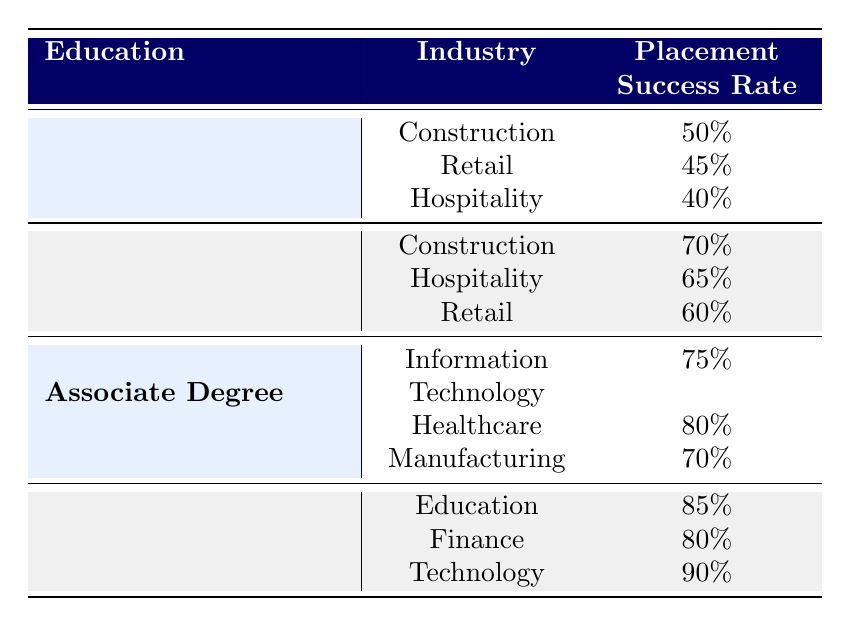What is the placement success rate for individuals with a High School Diploma in Hospitality? According to the table, the placement success rate for individuals with a High School Diploma in Hospitality is listed directly next to that category, which shows a rate of 65%.
Answer: 65% Which industry has the highest placement success rate for individuals with a Bachelor's Degree? Referring to the table, the placement success rates for individuals with a Bachelor's Degree across different industries are 85%, 80%, and 90%. The highest among these is 90% in Technology.
Answer: 90% Is the placement success rate for individuals with No Formal Education in Retail higher than that in Hospitality? In the table, the success rate for individuals with No Formal Education in Retail is 45%, while the rate in Hospitality is 40%. Since 45% is greater than 40%, the statement is true.
Answer: Yes What is the total placement success rate for Associate Degree holders across all industries listed? To find the total placement success rate for Associate Degree holders, add their rates together: 75% + 80% + 70% = 225%. To find the average, divide by the number of industries (3), resulting in an average rate of 75%.
Answer: 75% Does the industry Construction have a higher placement success rate for High School Diploma holders compared to No Formal Education? In the table, the placement success rate for Construction with a High School Diploma is 70%, while for No Formal Education it is 50%. Since 70% is greater than 50%, the statement is true.
Answer: Yes What is the difference in placement success rates between individuals with a Bachelor's Degree in Education and those with an Associate Degree in Healthcare? From the table, the placement success rate for Bachelor's Degree in Education is 85%, and for Associate Degree in Healthcare, it is 80%. The difference is calculated as 85% - 80% = 5%.
Answer: 5% Which educational qualification has the lowest placement success rate in the Construction industry? The table shows that No Formal Education in Construction has a success rate of 50%, while High School Diploma and Associate Degree individuals have higher rates (70% and higher). Therefore, No Formal Education has the lowest success rate in that industry.
Answer: No Formal Education What is the average placement success rate for individuals with High School Diplomas across all industries? The rates for High School Diploma holders are 70% in Construction, 65% in Hospitality, and 60% in Retail. Adding these gives 70 + 65 + 60 = 195. Dividing by the number of industries (3) results in an average of 65%.
Answer: 65% 